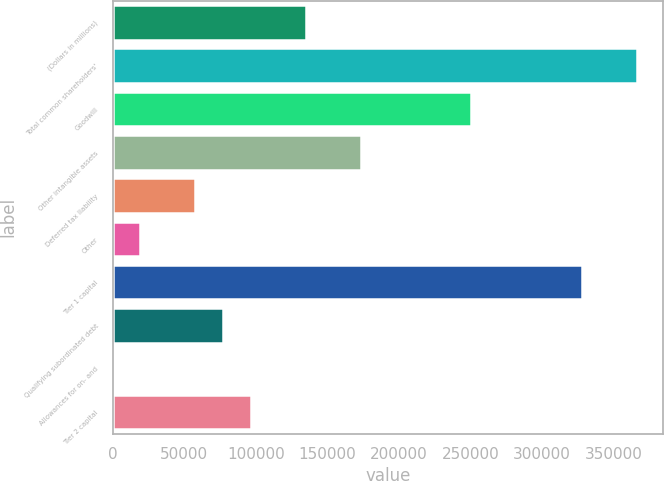<chart> <loc_0><loc_0><loc_500><loc_500><bar_chart><fcel>(Dollars in millions)<fcel>Total common shareholders'<fcel>Goodwill<fcel>Other intangible assets<fcel>Deferred tax liability<fcel>Other<fcel>Tier 1 capital<fcel>Qualifying subordinated debt<fcel>Allowances for on- and<fcel>Tier 2 capital<nl><fcel>134984<fcel>366315<fcel>250650<fcel>173539<fcel>57873.8<fcel>19318.6<fcel>327760<fcel>77151.4<fcel>41<fcel>96429<nl></chart> 